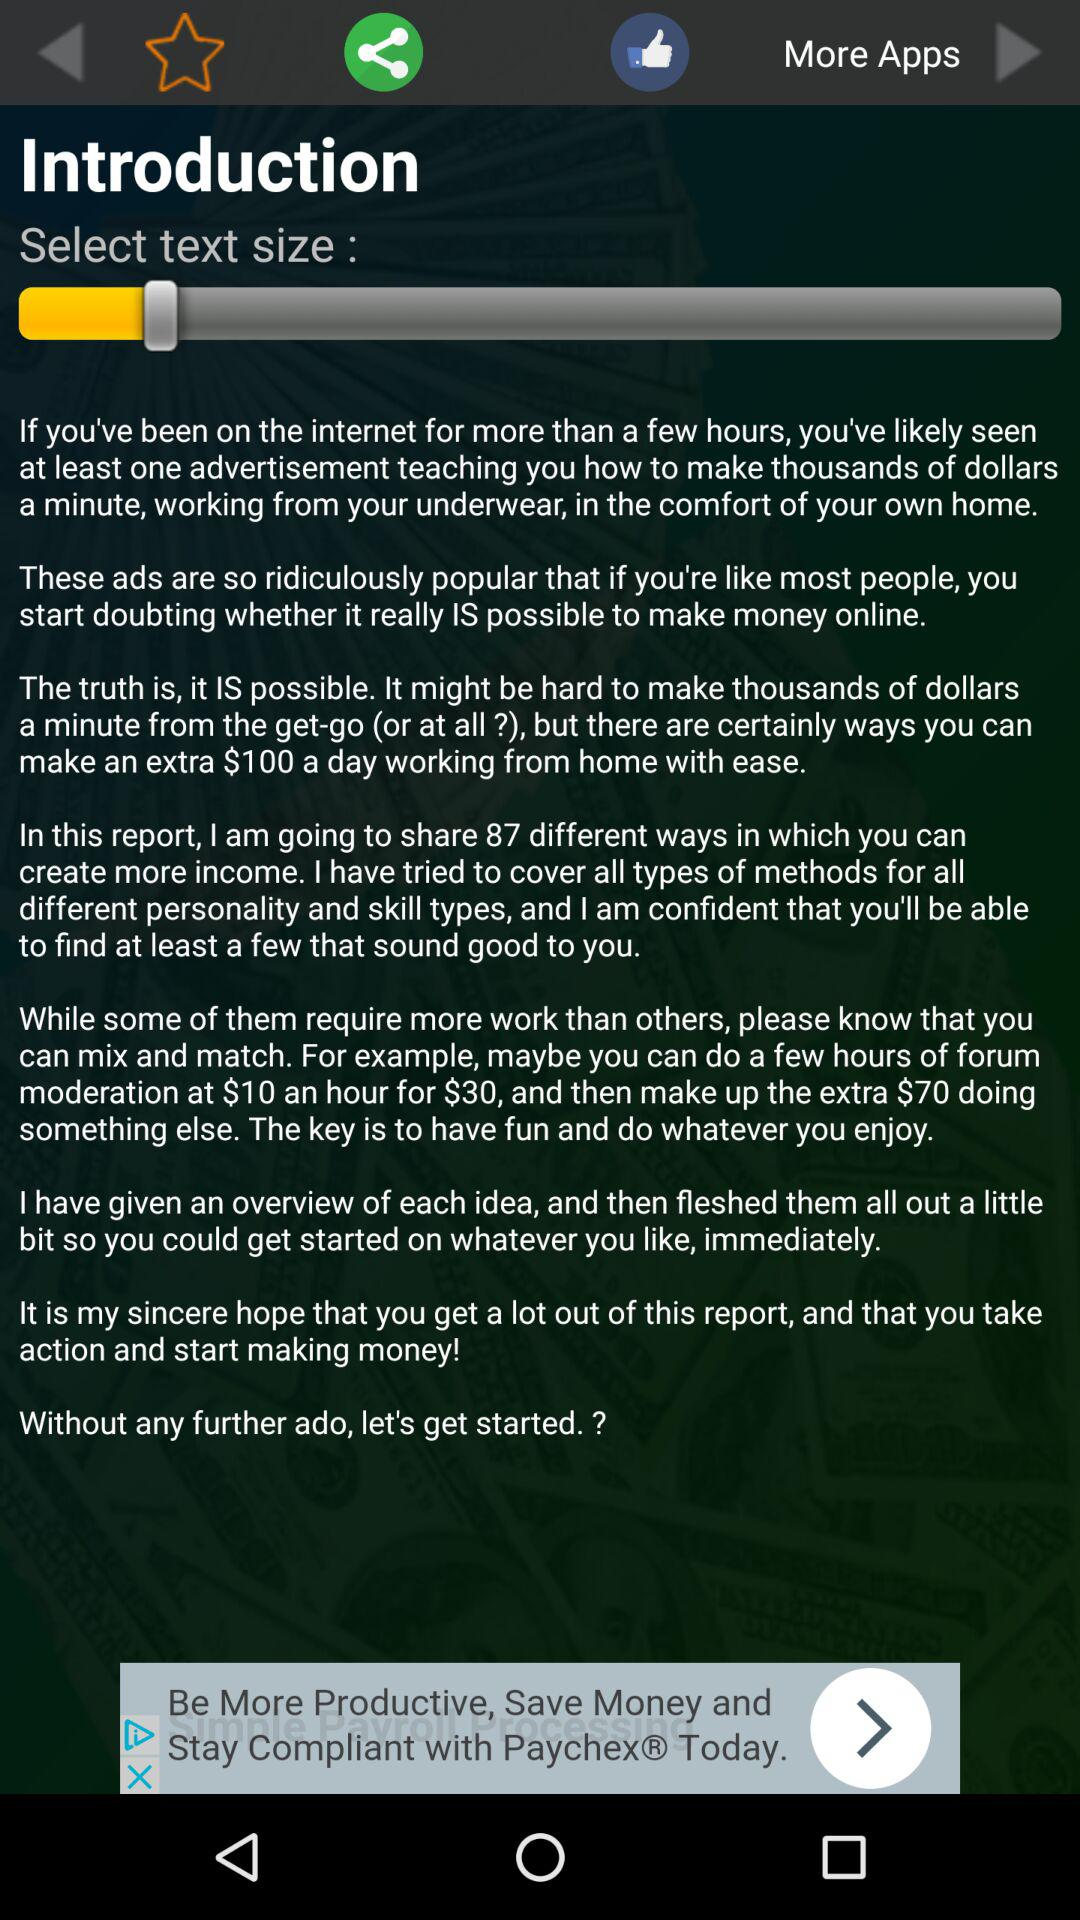How many dollars does the author suggest you can make in a day?
Answer the question using a single word or phrase. $100 